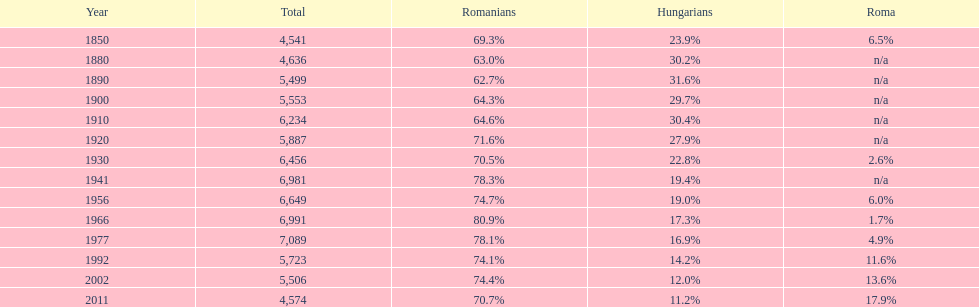In what year was there the largest percentage of hungarians? 1890. 